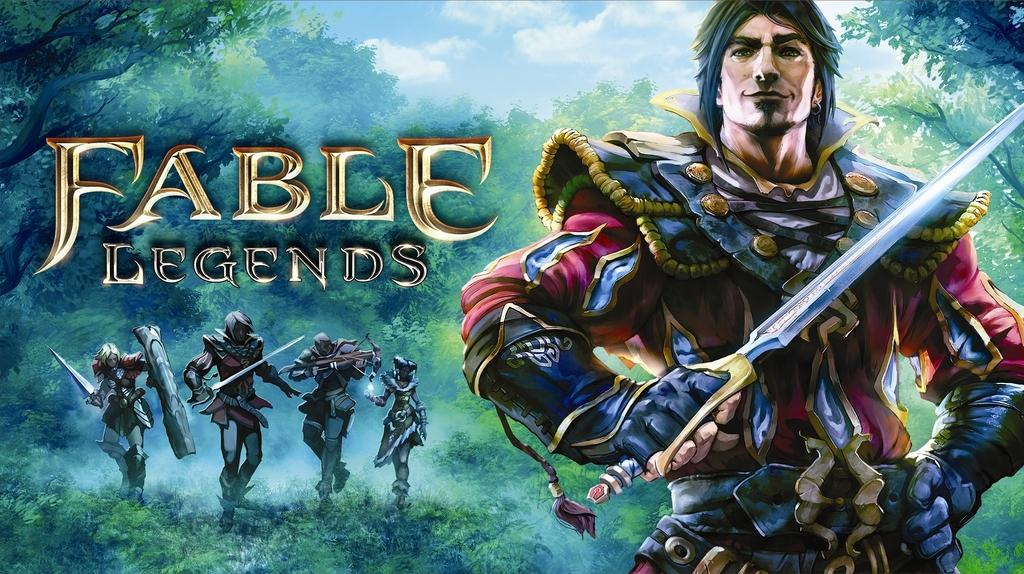<image>
Relay a brief, clear account of the picture shown. A Fable Legends poster with 5 characters on it. 